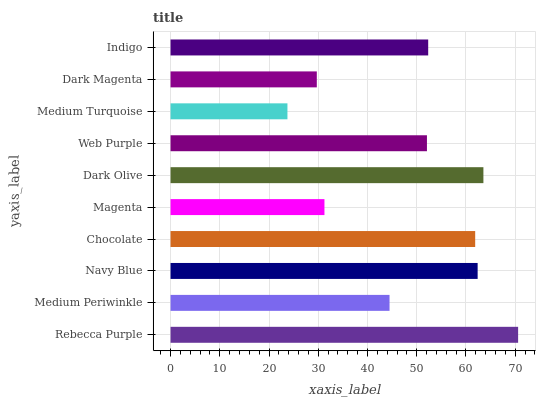Is Medium Turquoise the minimum?
Answer yes or no. Yes. Is Rebecca Purple the maximum?
Answer yes or no. Yes. Is Medium Periwinkle the minimum?
Answer yes or no. No. Is Medium Periwinkle the maximum?
Answer yes or no. No. Is Rebecca Purple greater than Medium Periwinkle?
Answer yes or no. Yes. Is Medium Periwinkle less than Rebecca Purple?
Answer yes or no. Yes. Is Medium Periwinkle greater than Rebecca Purple?
Answer yes or no. No. Is Rebecca Purple less than Medium Periwinkle?
Answer yes or no. No. Is Indigo the high median?
Answer yes or no. Yes. Is Web Purple the low median?
Answer yes or no. Yes. Is Medium Turquoise the high median?
Answer yes or no. No. Is Indigo the low median?
Answer yes or no. No. 